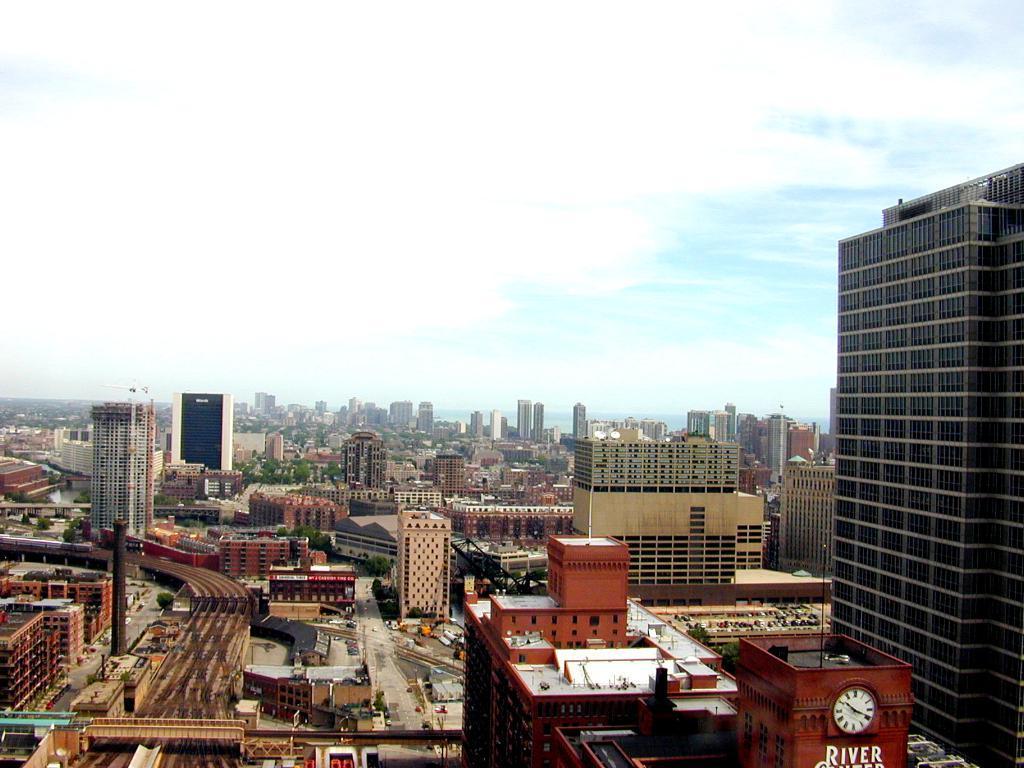How would you summarize this image in a sentence or two? This image consists of many buildings and skyscrapers. At the top, there are clouds in the sky. And we can see the roads. 